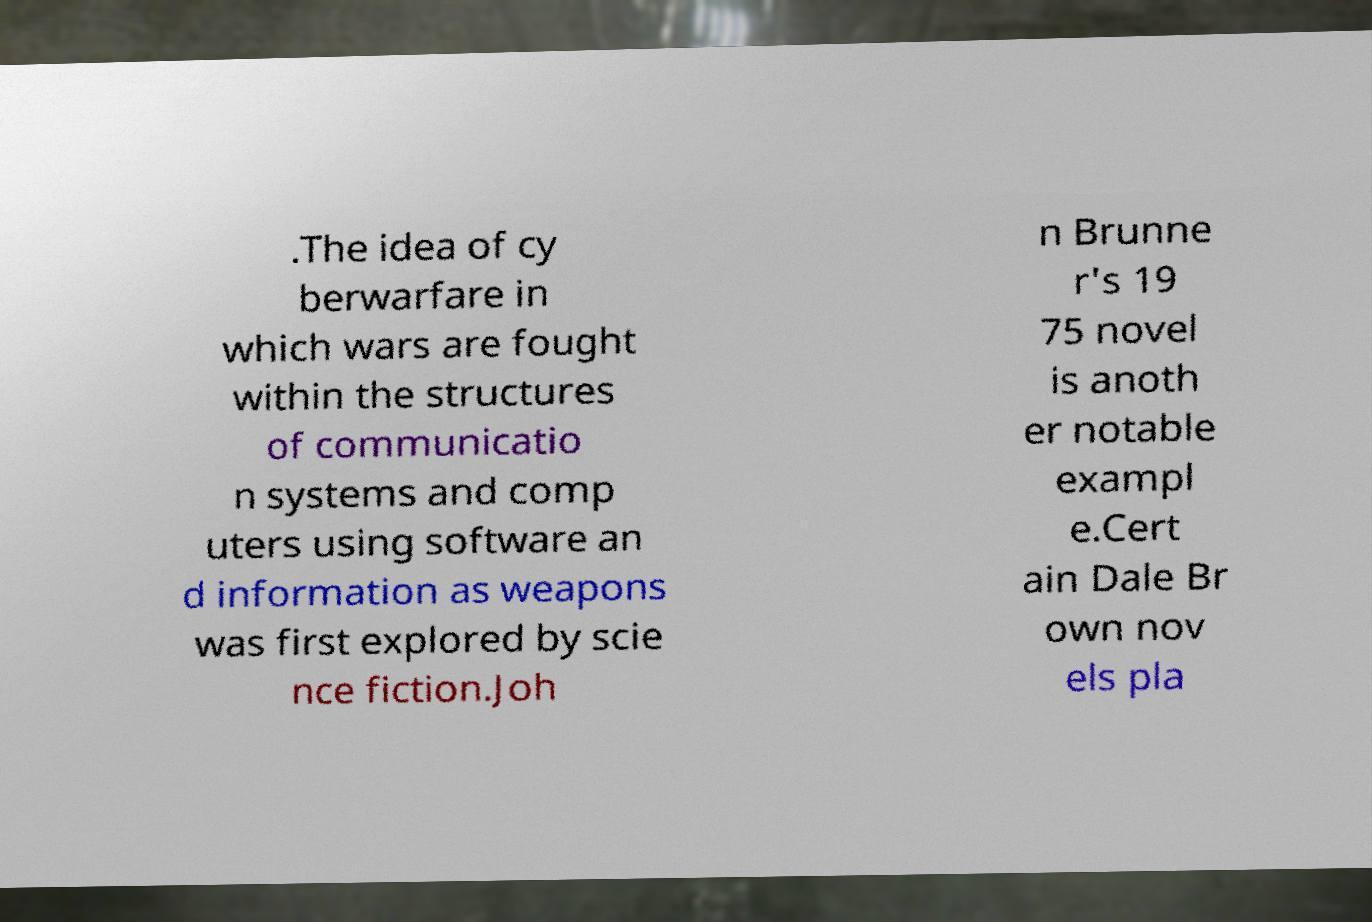What messages or text are displayed in this image? I need them in a readable, typed format. .The idea of cy berwarfare in which wars are fought within the structures of communicatio n systems and comp uters using software an d information as weapons was first explored by scie nce fiction.Joh n Brunne r's 19 75 novel is anoth er notable exampl e.Cert ain Dale Br own nov els pla 